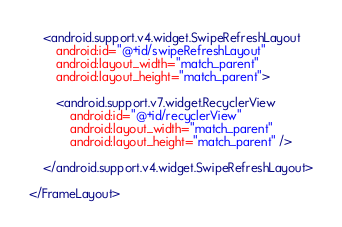<code> <loc_0><loc_0><loc_500><loc_500><_XML_>
    <android.support.v4.widget.SwipeRefreshLayout
        android:id="@+id/swipeRefreshLayout"
        android:layout_width="match_parent"
        android:layout_height="match_parent">

        <android.support.v7.widget.RecyclerView
            android:id="@+id/recyclerView"
            android:layout_width="match_parent"
            android:layout_height="match_parent" />

    </android.support.v4.widget.SwipeRefreshLayout>

</FrameLayout></code> 